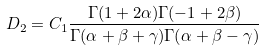Convert formula to latex. <formula><loc_0><loc_0><loc_500><loc_500>D _ { 2 } = C _ { 1 } \frac { \Gamma ( 1 + 2 \alpha ) \Gamma ( - 1 + 2 \beta ) } { \Gamma ( \alpha + \beta + \gamma ) \Gamma ( \alpha + \beta - \gamma ) }</formula> 